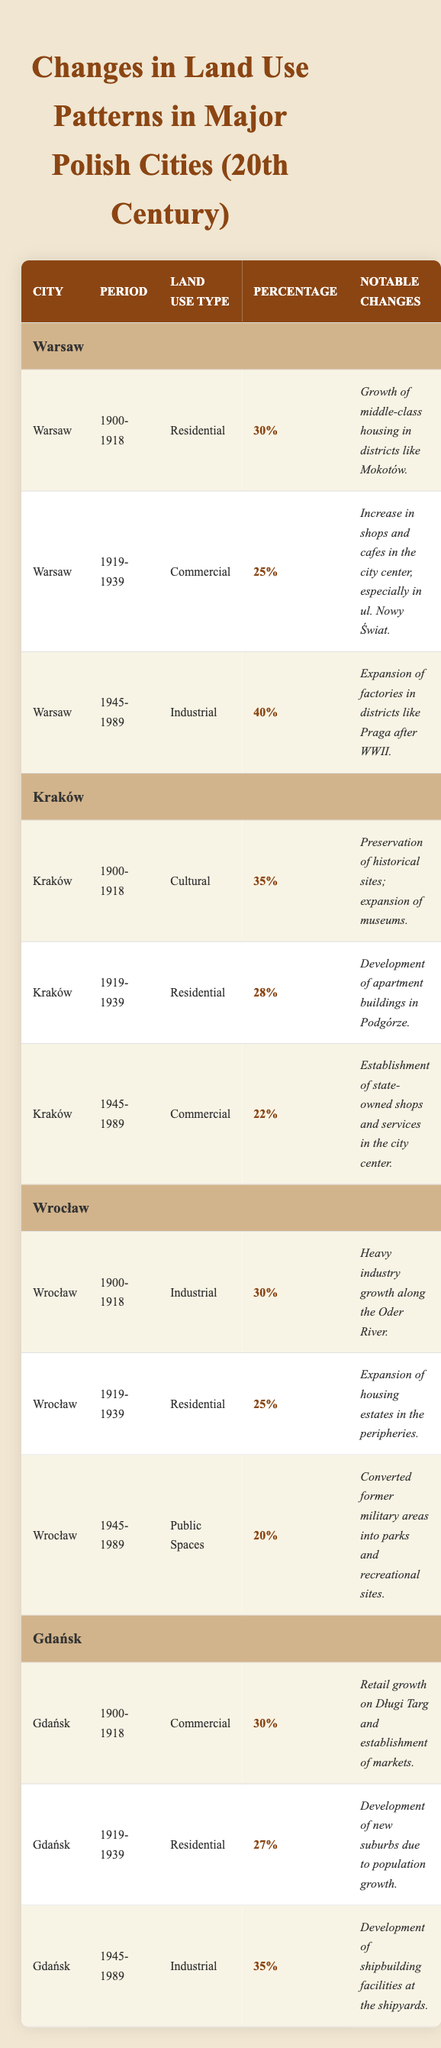What is the land use type for Warsaw in the period 1945-1989? In the table, looking under Warsaw for the period 1945-1989, the land use type listed is Industrial.
Answer: Industrial Which city had the highest percentage of land used for Residential purposes in the 1900-1918 period? In the 1900-1918 period, Warsaw had 30% for Residential, Kraków had 35% for Cultural, and Wrocław had 30% for Industrial, but Kraków had the highest percentage with 35% for Cultural, not Residential. Therefore, it appears that Kraków has the highest percentage for Cultural, not Residential.
Answer: 35% What are the notable changes in land use for Kraków during the period 1945-1989? By checking the table, for Kraków in 1945-1989, the notable changes stated are the establishment of state-owned shops and services in the city center.
Answer: Establishment of state-owned shops and services What is the total percentage of land use for Industrial purposes across all cities during the 1945-1989 period? By examining the table for each city in the 1945-1989 period: Warsaw has 40%, Gdańsk has 35%, Wrocław has 0% (not applicable), and Kraków has 22%. The total is 40 + 35 + 0 + 22 = 97%.
Answer: 97% Which city saw a shift from Residential to Commercial land use between 1919-1939? In that period, Warsaw shifted from Residential (30% in 1900-1918) to Commercial (25% in 1919-1939). Kraków and Wrocław both sustained Residential, while Gdańsk also maintained Residential. Thus, Warsaw is the only city that shifted from Residential in 1900-1918 to Commercial in 1919-1939.
Answer: Warsaw What is the significance of the changes in land use for Gdańsk from 1919-1939 to 1945-1989? In 1919-1939, Gdańsk had 27% for Residential, while in 1945-1989, it shifted to 35% for Industrial. The notable change indicates a transition from Residential growth to a significant focus on Industrial development, especially in shipbuilding facilities.
Answer: Shift from Residential to Industrial Which period had the highest percentage of land use classified as Public Spaces in Wrocław? According to the table, the highest percentage for Public Spaces in Wrocław is during the period of 1945-1989, reaching 20%. In other periods (1900-1918 and 1919-1939), it was not classified under Public Spaces.
Answer: 20% Did any city maintain a consistent land use type across all periods? By reviewing the table entries, no city maintained the same land use type across all observed periods. Each city underwent transitions in land use types over the decades outlined.
Answer: No What was the notable change in Wrocław for the land use type during 1945-1989? In the table, Wrocław transitioned to focus on Public Spaces, specifically converting former military areas into parks and recreational sites, highlighting a transformation in urban development strategy.
Answer: Conversion of military areas into parks What was the dominant land use type in Kraków during 1900-1918? In the 1900-1918 period for Kraków, the land use type was Cultural, with a percentage of 35%, which was higher than any other types in the same city during this period.
Answer: Cultural What percentage of land use in Gdańsk during 1900-1918 was designated for Commercial purposes? In Gdańsk for the period of 1900-1918, the land use type was Commercial at 30%, which indicates a significant focus on retail and market establishments during that period.
Answer: 30% 